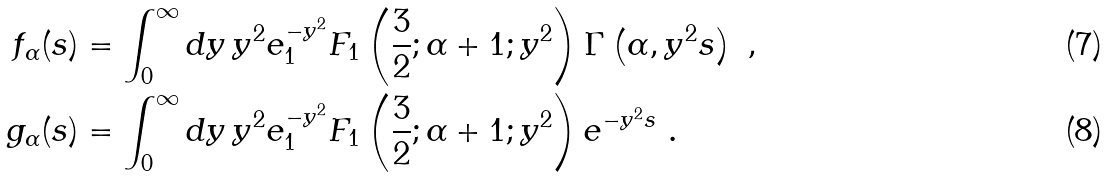<formula> <loc_0><loc_0><loc_500><loc_500>f _ { \alpha } ( s ) & = \int _ { 0 } ^ { \infty } d y \, y ^ { 2 } e ^ { - y ^ { 2 } } _ { 1 } \text {F} _ { 1 } \left ( \frac { 3 } { 2 } ; \alpha + 1 ; y ^ { 2 } \right ) \Gamma \left ( \alpha , y ^ { 2 } s \right ) \ , \\ g _ { \alpha } ( s ) & = \int _ { 0 } ^ { \infty } d y \, y ^ { 2 } e ^ { - y ^ { 2 } } _ { 1 } \text {F} _ { 1 } \left ( \frac { 3 } { 2 } ; \alpha + 1 ; y ^ { 2 } \right ) e ^ { - y ^ { 2 } s } \ .</formula> 